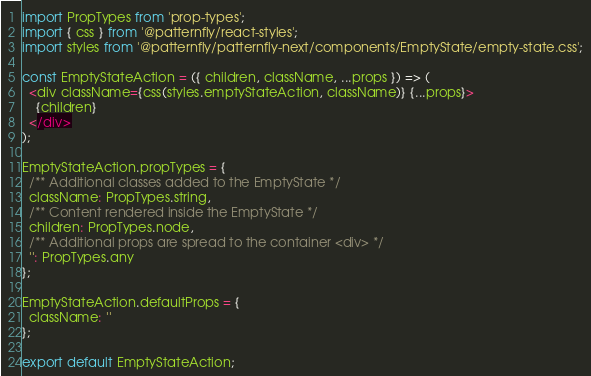Convert code to text. <code><loc_0><loc_0><loc_500><loc_500><_JavaScript_>import PropTypes from 'prop-types';
import { css } from '@patternfly/react-styles';
import styles from '@patternfly/patternfly-next/components/EmptyState/empty-state.css';

const EmptyStateAction = ({ children, className, ...props }) => (
  <div className={css(styles.emptyStateAction, className)} {...props}>
    {children}
  </div>
);

EmptyStateAction.propTypes = {
  /** Additional classes added to the EmptyState */
  className: PropTypes.string,
  /** Content rendered inside the EmptyState */
  children: PropTypes.node,
  /** Additional props are spread to the container <div> */
  '': PropTypes.any
};

EmptyStateAction.defaultProps = {
  className: ''
};

export default EmptyStateAction;
</code> 